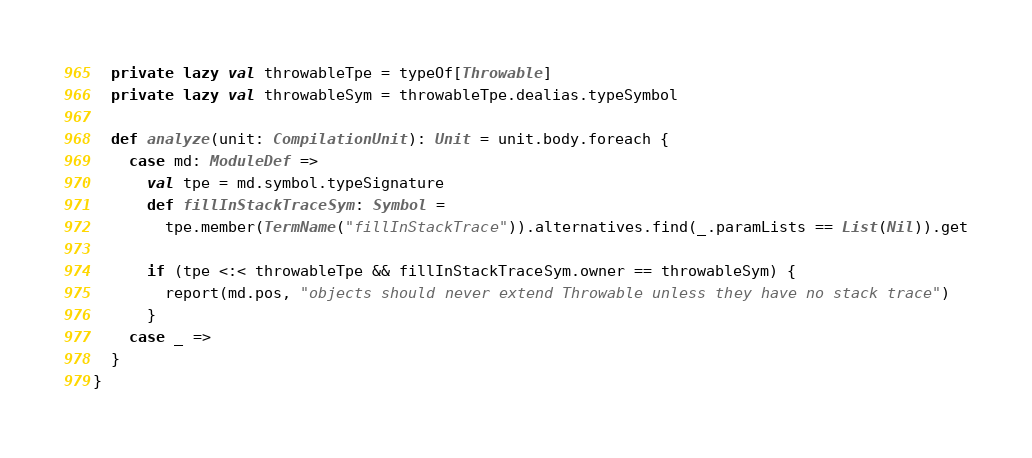<code> <loc_0><loc_0><loc_500><loc_500><_Scala_>
  private lazy val throwableTpe = typeOf[Throwable]
  private lazy val throwableSym = throwableTpe.dealias.typeSymbol

  def analyze(unit: CompilationUnit): Unit = unit.body.foreach {
    case md: ModuleDef =>
      val tpe = md.symbol.typeSignature
      def fillInStackTraceSym: Symbol =
        tpe.member(TermName("fillInStackTrace")).alternatives.find(_.paramLists == List(Nil)).get

      if (tpe <:< throwableTpe && fillInStackTraceSym.owner == throwableSym) {
        report(md.pos, "objects should never extend Throwable unless they have no stack trace")
      }
    case _ =>
  }
}
</code> 